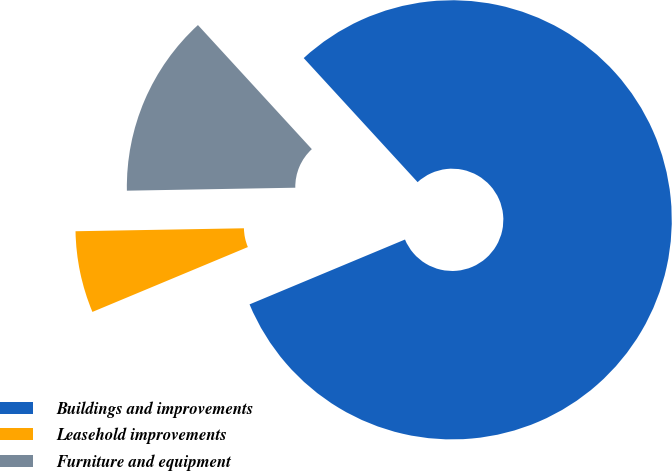Convert chart. <chart><loc_0><loc_0><loc_500><loc_500><pie_chart><fcel>Buildings and improvements<fcel>Leasehold improvements<fcel>Furniture and equipment<nl><fcel>80.52%<fcel>6.01%<fcel>13.46%<nl></chart> 